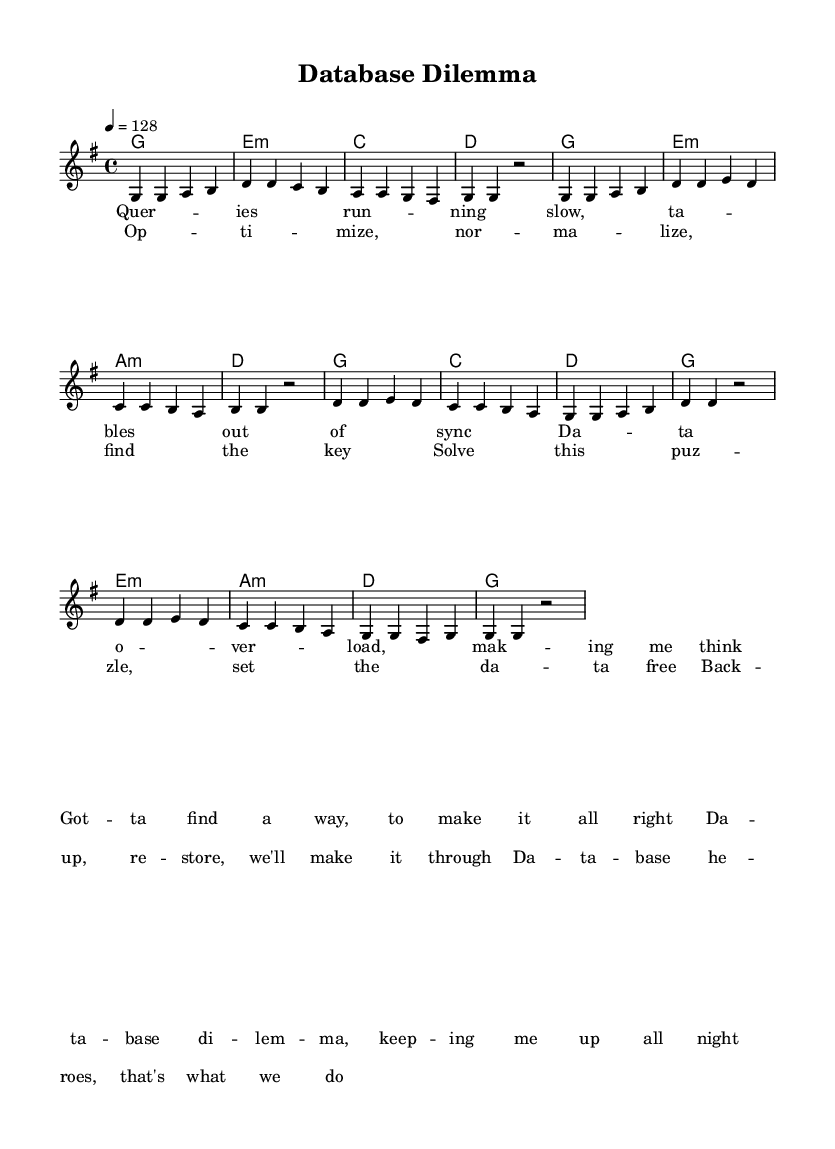What is the key signature of this music? The key signature is G major, which has one sharp (F#). You can tell this by looking at the key signature indicated at the beginning of the score, before any notes are placed.
Answer: G major What is the time signature of this music? The time signature is 4/4, meaning there are four beats in each measure and the quarter note gets one beat. This can be identified by the time signature notation found at the beginning of the score right next to the key signature.
Answer: 4/4 What is the tempo of this piece? The tempo is 128 beats per minute. This is found above the staff indicated by the '4 = 128' marking, which tells the performer how fast the piece should be played.
Answer: 128 How many measures are in the verse? The verse consists of 8 measures, as indicated by the segmented structure of the notated music in the melody section. Each section of music separated by the vertical lines represents one measure.
Answer: 8 What musical forms are used in this piece? The piece includes a verse and a chorus. You can distinguish between the two by observing the lyrics and the structure; both sections are labeled separately in the scoring section.
Answer: Verse and Chorus How many chords are used in the chorus? There are 6 chords in the chorus as seen in the chord notation, where each chord is specified on a new line right after the sections of melody.
Answer: 6 What is the lyrical theme of this piece? The lyrical theme revolves around data management and problem-solving, which can be inferred from the content of the lyrics in both the verse and chorus that discuss topics like optimization and database dilemmas.
Answer: Data management 